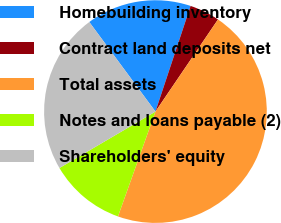Convert chart. <chart><loc_0><loc_0><loc_500><loc_500><pie_chart><fcel>Homebuilding inventory<fcel>Contract land deposits net<fcel>Total assets<fcel>Notes and loans payable (2)<fcel>Shareholders' equity<nl><fcel>15.24%<fcel>4.38%<fcel>45.97%<fcel>11.08%<fcel>23.33%<nl></chart> 